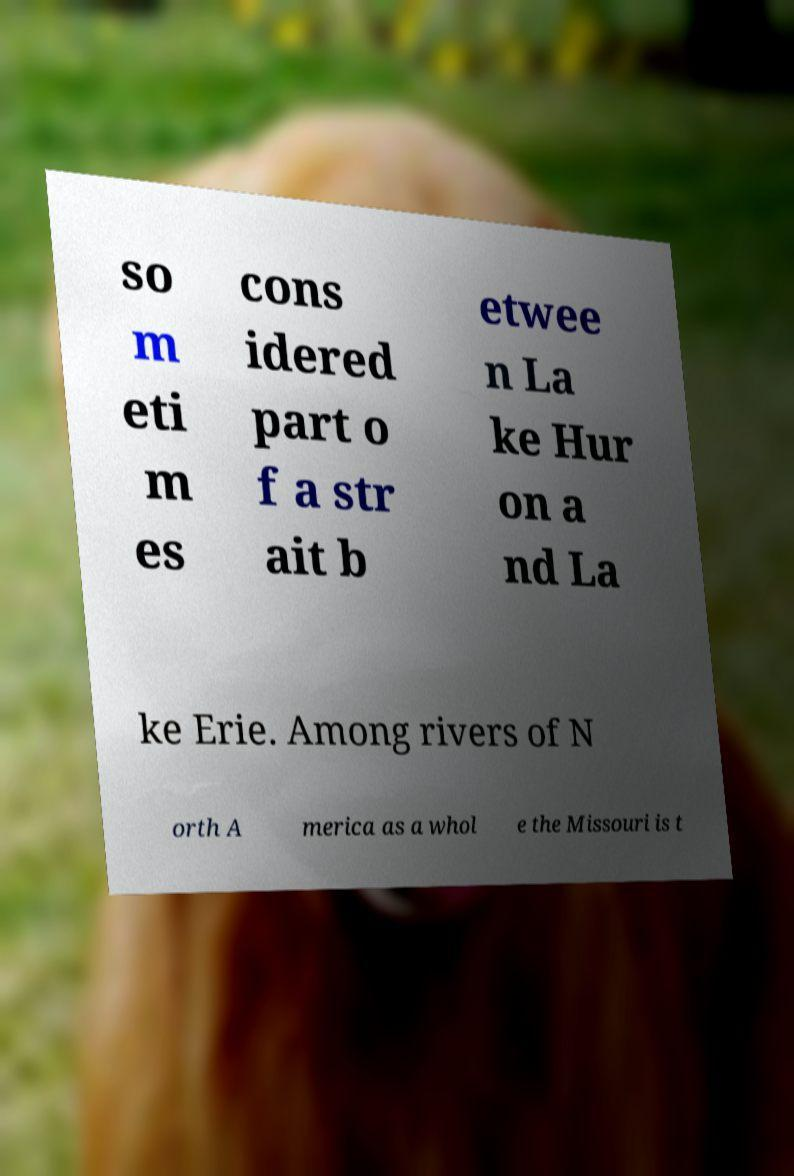Could you assist in decoding the text presented in this image and type it out clearly? so m eti m es cons idered part o f a str ait b etwee n La ke Hur on a nd La ke Erie. Among rivers of N orth A merica as a whol e the Missouri is t 